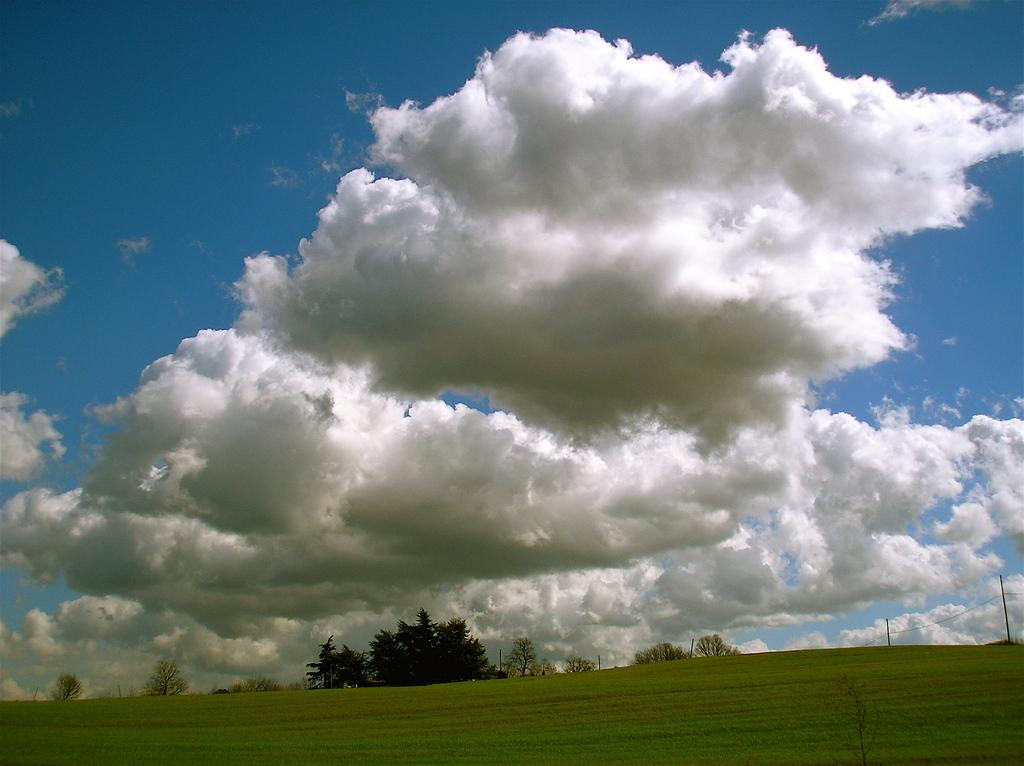What can be seen in the sky in the image? The sky with clouds is visible in the image. What type of vegetation is present in the image? There are trees in the image. What is the ground covered with in the image? There is grass in the image. What man-made structure can be seen in the image? There is a pole with wires in the image. What type of card is being used to play a game in the image? There is no card or game present in the image; it features a sky with clouds, trees, grass, and a pole with wires. 